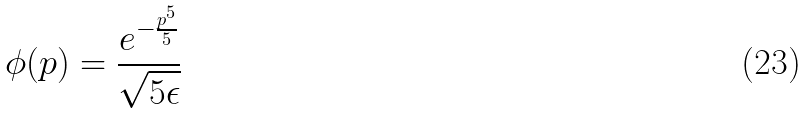<formula> <loc_0><loc_0><loc_500><loc_500>\phi ( p ) = \frac { e ^ { - \frac { p ^ { 5 } } { 5 } } } { \sqrt { 5 \epsilon } }</formula> 